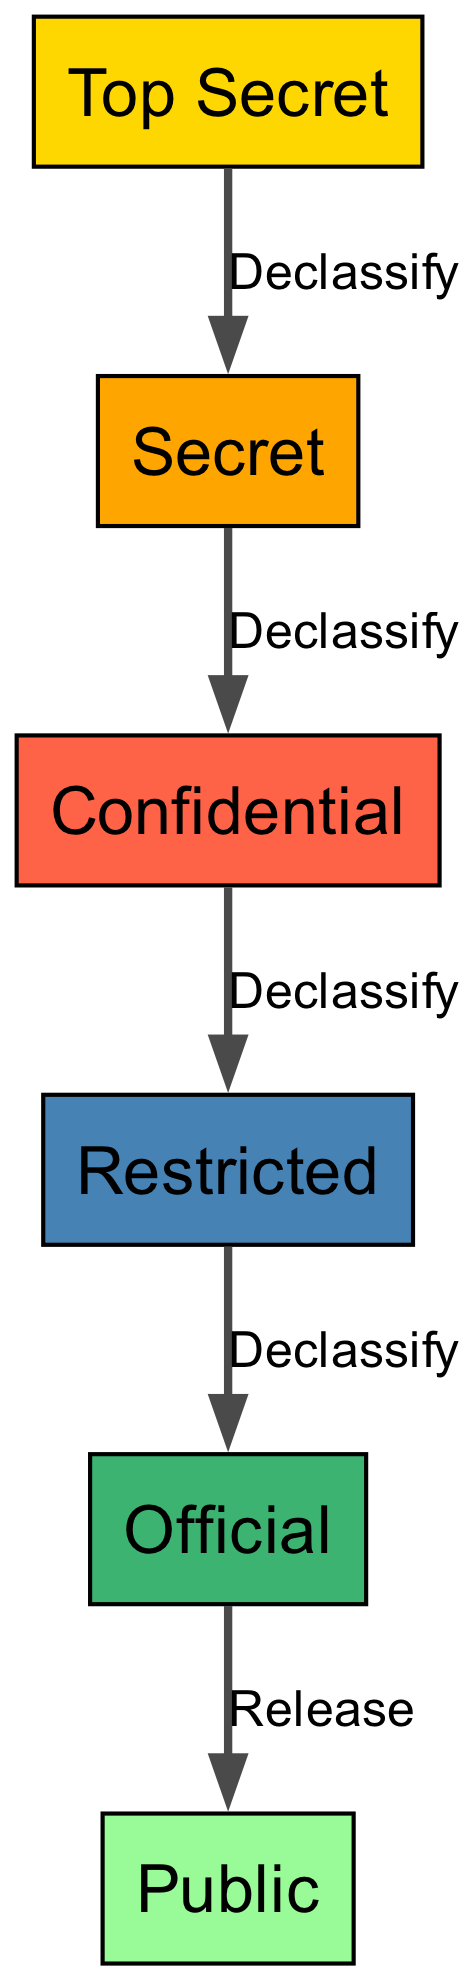What is the highest classification level in the diagram? The diagram shows several classification levels, and the highest one listed is "Top Secret."
Answer: Top Secret How many nodes are present in the directed graph? The diagram lists six classification levels, which are represented as nodes. Therefore, the number of nodes is six.
Answer: 6 What level comes after "Confidential" in the hierarchy? The diagram indicates that "Confidential" declassifies to "Restricted," meaning "Restricted" is the level that follows "Confidential."
Answer: Restricted What is the relationship labeled between "Official" and "Public"? The directed edge drawn between "Official" and "Public" is labeled "Release," indicating that "Official" can be released to the "Public."
Answer: Release Which node has edges coming from the highest classification levels? The "Top Secret" node has an edge leading to "Secret," indicating it influences this next classification level.
Answer: Secret What is the total number of edges in the diagram? Upon counting the directed connections between nodes, the diagram has five edges connecting the various classification levels.
Answer: 5 What level must be reached to access "Public" information? The diagram indicates that information must be declassified through "Official" to reach "Public," showing a clear progression.
Answer: Official Which classification level can be reduced from "Restricted"? The edge labeled "Declassify" shows that "Restricted" can be reduced to "Official," which is the level that follows.
Answer: Official If a document is classified as "Secret," what will be the next level after declassification? The flow of declassification shows that after "Secret," the next level would be "Confidential," following the directed edge provided in the diagram.
Answer: Confidential 